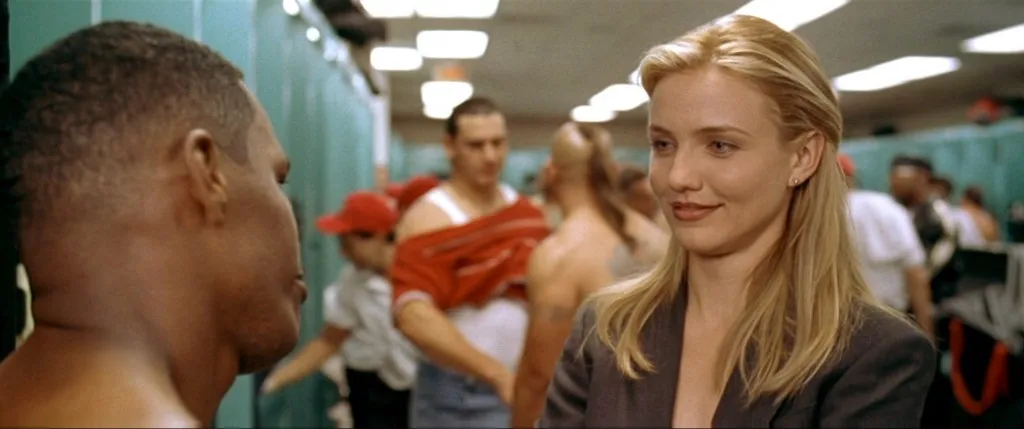How did these characters end up in their current roles? The woman might have excelled academically, earning prestigious degrees in law or business and climbing the corporate ladder through sheer determination and intelligence. Her journey could include earning a scholarship to a top university, interning at a major firm, and quickly making a name for herself among her peers. The man, possibly an entrepreneur or a key client, could have a background in business or tech, launching successful startups or managing significant projects. His path could involve overcoming numerous obstacles, learning from failures, and ultimately achieving prominence in his field through creativity and resilience. Can you elaborate on a pivotal moment in their careers that brought them together? A pivotal moment for their meeting might have been during a high-stakes negotiation for a groundbreaking partnership. The woman, renowned for her negotiating skills, was brought in to represent a major corporation looking to innovate in a new market. Meanwhile, the man was the visionary behind a tech company with a revolutionary product. Their first meeting could have been charged with tension and anticipation, both understanding the stakes at play. Through intense discussions, late-night strategy sessions, and a shared vision for innovation, they forged a powerful business alliance, laying the groundwork for a project that would redefine their respective industries. Their mutual respect and admiration for each other's expertise grew from this collaboration, marking the beginning of a dynamic professional relationship. What was one specific challenge they overcame together? One specific challenge they overcame together was navigating a challenging regulatory environment that threatened to derail their joint venture. Faced with stringent and unexpected government regulations, they had to quickly adapt their strategy. The woman utilized her extensive legal knowledge to interpret the complex regulations and devise a compliance strategy, while the man leveraged his innovative mindset to tweak their product design, making it more adaptable. Their ability to pivot quickly and work cohesively under pressure not only saved their collaboration but also set a new standard for industry compliance and innovation. This experience strengthened their partnership and demonstrated their capability to overcome significant hurdles together. 